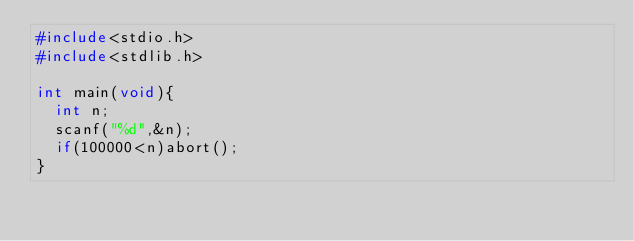Convert code to text. <code><loc_0><loc_0><loc_500><loc_500><_C_>#include<stdio.h>
#include<stdlib.h>

int main(void){
  int n;
  scanf("%d",&n);
  if(100000<n)abort();
}
</code> 